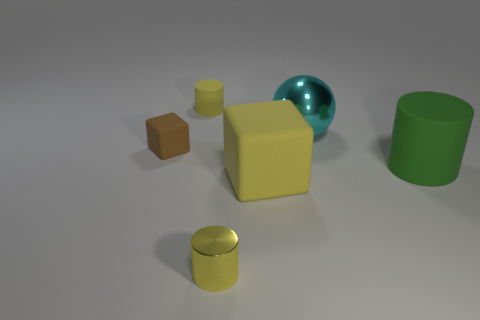There is a big thing that is on the left side of the big cylinder and behind the big yellow block; what material is it made of? The large object to the left of the cylinder and behind the yellow block appears to be made of a shiny metal, reflective and smooth indicative of materials like steel or aluminum commonly used in 3D renderings for a sleek appearance. 